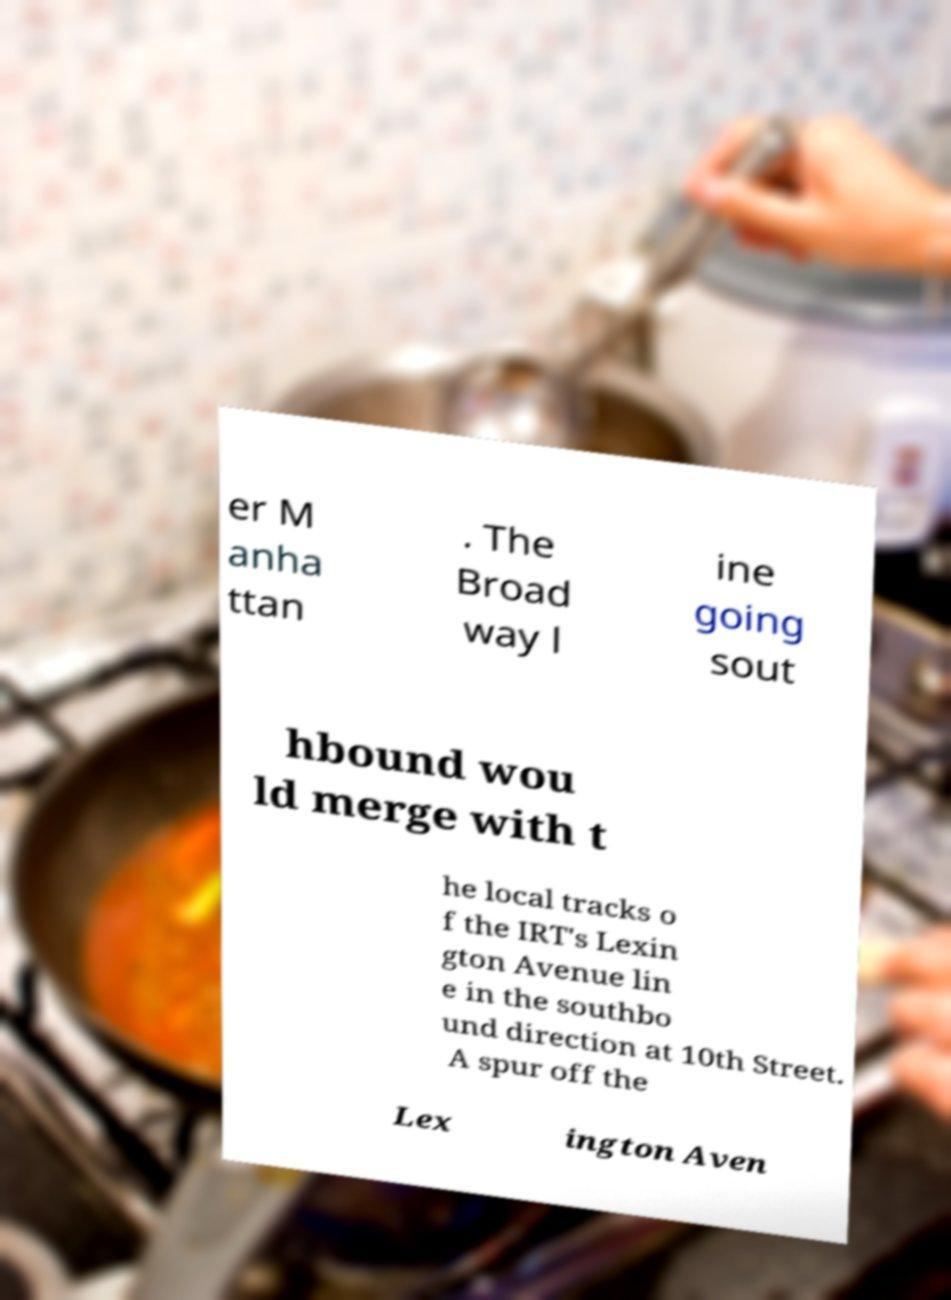Could you assist in decoding the text presented in this image and type it out clearly? er M anha ttan . The Broad way l ine going sout hbound wou ld merge with t he local tracks o f the IRT's Lexin gton Avenue lin e in the southbo und direction at 10th Street. A spur off the Lex ington Aven 